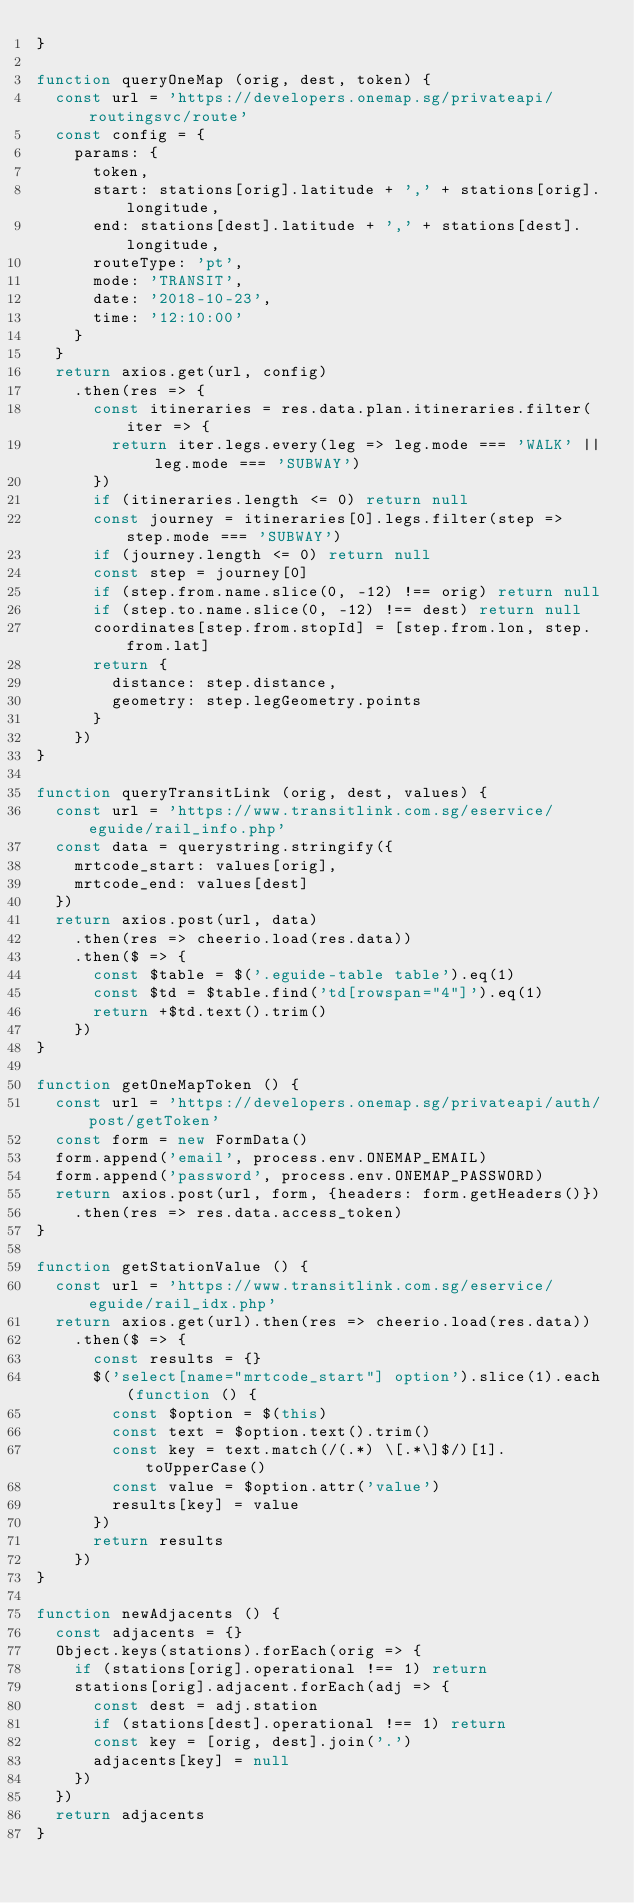<code> <loc_0><loc_0><loc_500><loc_500><_JavaScript_>}

function queryOneMap (orig, dest, token) {
  const url = 'https://developers.onemap.sg/privateapi/routingsvc/route'
  const config = {
    params: {
      token,
      start: stations[orig].latitude + ',' + stations[orig].longitude,
      end: stations[dest].latitude + ',' + stations[dest].longitude,
      routeType: 'pt',
      mode: 'TRANSIT',
      date: '2018-10-23',
      time: '12:10:00'
    }
  }
  return axios.get(url, config)
    .then(res => {
      const itineraries = res.data.plan.itineraries.filter(iter => {
        return iter.legs.every(leg => leg.mode === 'WALK' || leg.mode === 'SUBWAY')
      })
      if (itineraries.length <= 0) return null
      const journey = itineraries[0].legs.filter(step => step.mode === 'SUBWAY')
      if (journey.length <= 0) return null
      const step = journey[0]
      if (step.from.name.slice(0, -12) !== orig) return null
      if (step.to.name.slice(0, -12) !== dest) return null
      coordinates[step.from.stopId] = [step.from.lon, step.from.lat]
      return {
        distance: step.distance,
        geometry: step.legGeometry.points
      }
    })
}

function queryTransitLink (orig, dest, values) {
  const url = 'https://www.transitlink.com.sg/eservice/eguide/rail_info.php'
  const data = querystring.stringify({
    mrtcode_start: values[orig],
    mrtcode_end: values[dest]
  })
  return axios.post(url, data)
    .then(res => cheerio.load(res.data))
    .then($ => {
      const $table = $('.eguide-table table').eq(1)
      const $td = $table.find('td[rowspan="4"]').eq(1)
      return +$td.text().trim()
    })
}

function getOneMapToken () {
  const url = 'https://developers.onemap.sg/privateapi/auth/post/getToken'
  const form = new FormData()
  form.append('email', process.env.ONEMAP_EMAIL)
  form.append('password', process.env.ONEMAP_PASSWORD)
  return axios.post(url, form, {headers: form.getHeaders()})
    .then(res => res.data.access_token)
}

function getStationValue () {
  const url = 'https://www.transitlink.com.sg/eservice/eguide/rail_idx.php'
  return axios.get(url).then(res => cheerio.load(res.data))
    .then($ => {
      const results = {}
      $('select[name="mrtcode_start"] option').slice(1).each(function () {
        const $option = $(this)
        const text = $option.text().trim()
        const key = text.match(/(.*) \[.*\]$/)[1].toUpperCase()
        const value = $option.attr('value')
        results[key] = value
      })
      return results
    })
}

function newAdjacents () {
  const adjacents = {}
  Object.keys(stations).forEach(orig => {
    if (stations[orig].operational !== 1) return
    stations[orig].adjacent.forEach(adj => {
      const dest = adj.station
      if (stations[dest].operational !== 1) return
      const key = [orig, dest].join('.')
      adjacents[key] = null
    })
  })
  return adjacents
}
</code> 